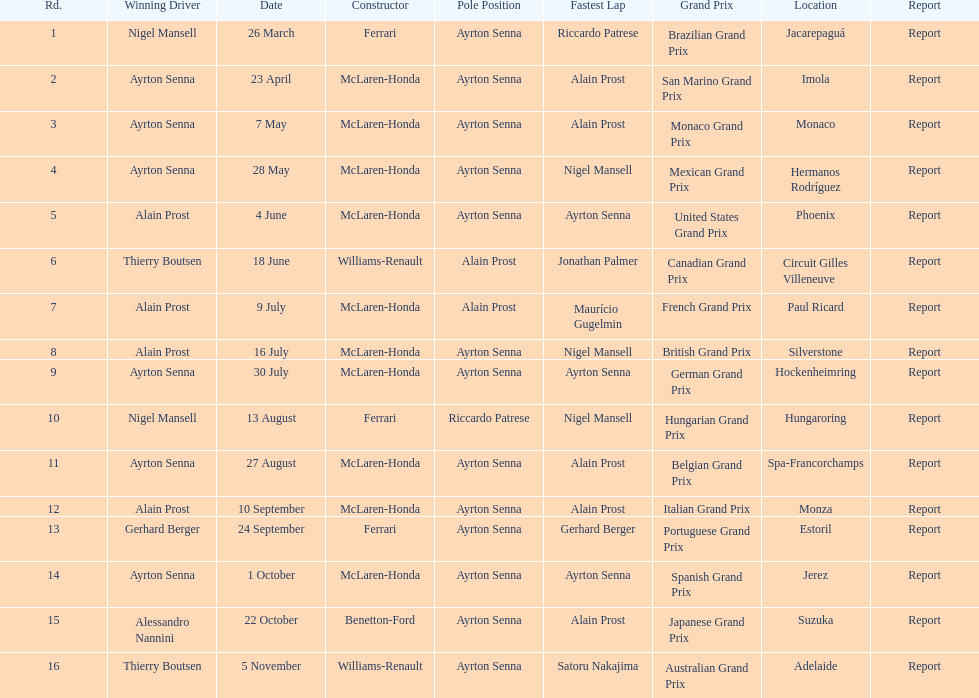What are all of the grand prix run in the 1989 formula one season? Brazilian Grand Prix, San Marino Grand Prix, Monaco Grand Prix, Mexican Grand Prix, United States Grand Prix, Canadian Grand Prix, French Grand Prix, British Grand Prix, German Grand Prix, Hungarian Grand Prix, Belgian Grand Prix, Italian Grand Prix, Portuguese Grand Prix, Spanish Grand Prix, Japanese Grand Prix, Australian Grand Prix. Of those 1989 formula one grand prix, which were run in october? Spanish Grand Prix, Japanese Grand Prix, Australian Grand Prix. Of those 1989 formula one grand prix run in october, which was the only one to be won by benetton-ford? Japanese Grand Prix. 